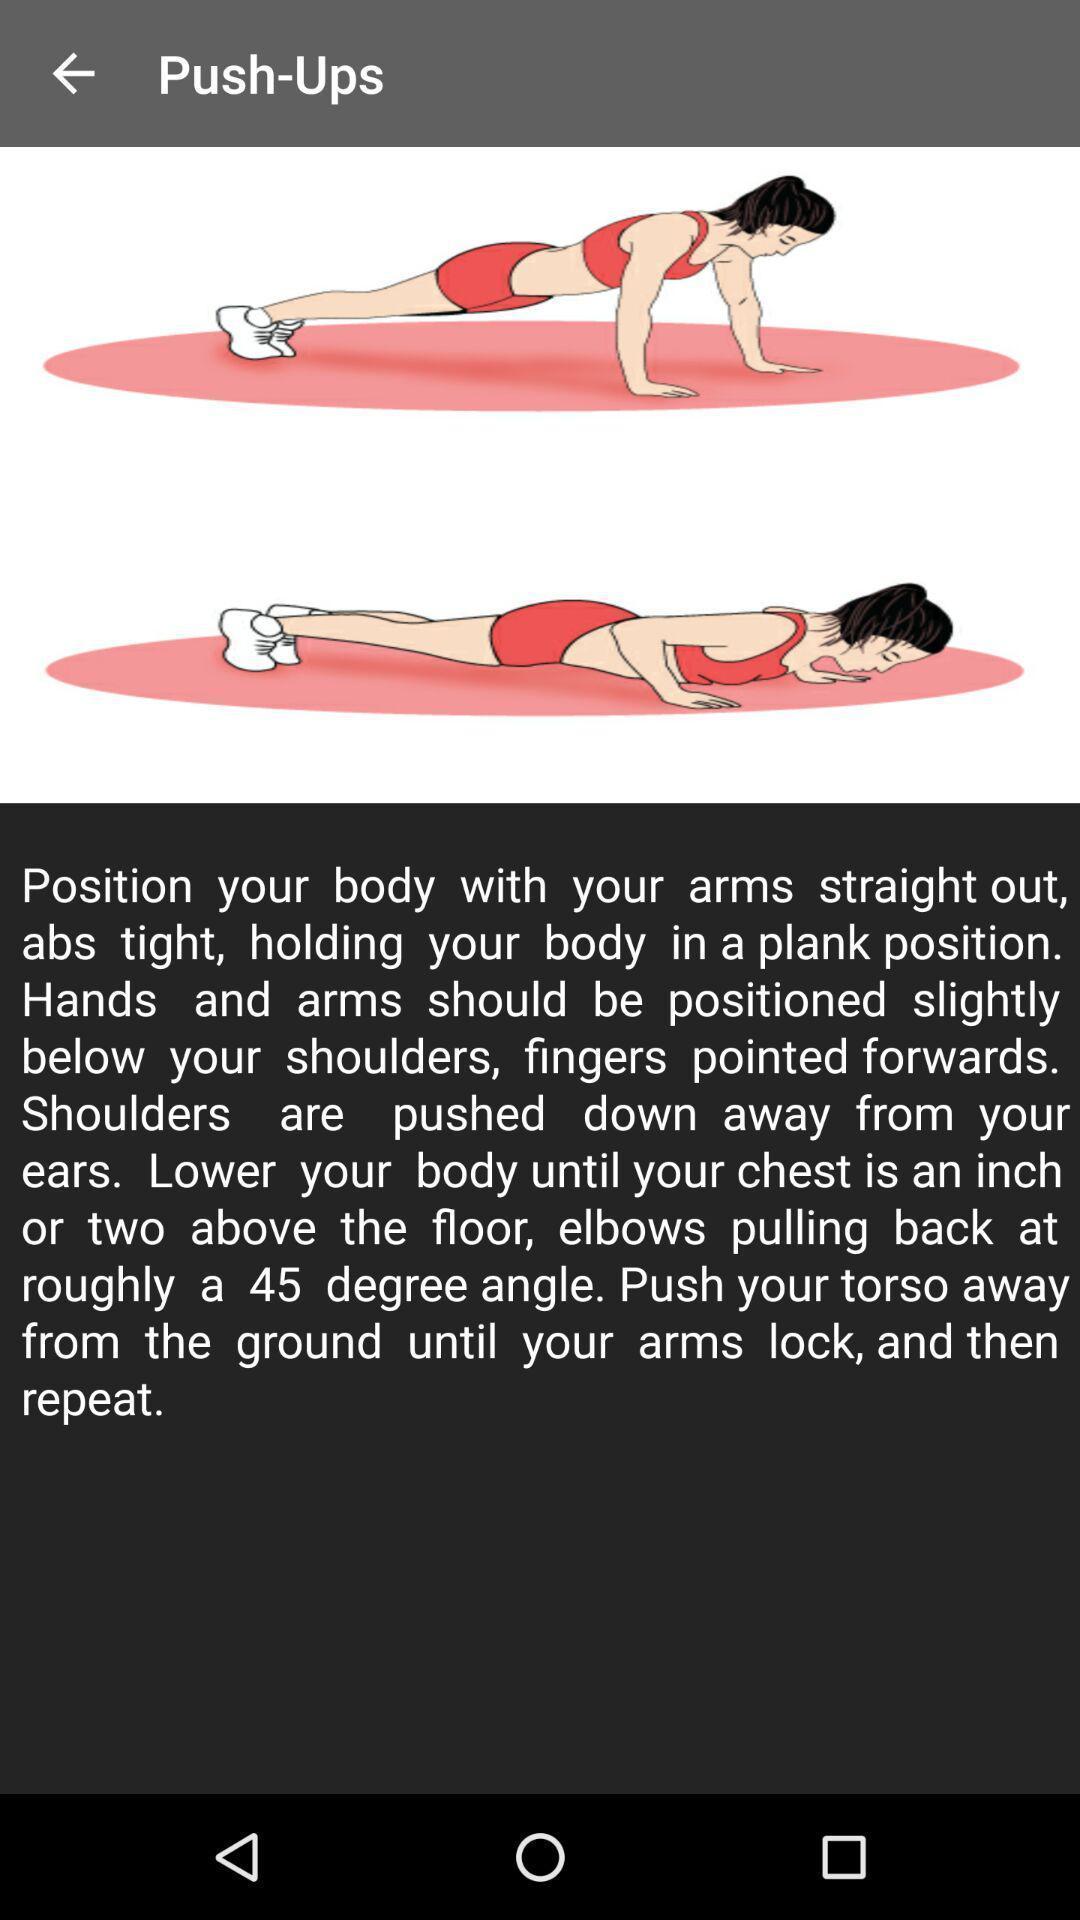Tell me about the visual elements in this screen capture. Page showing how to do push-ups. 